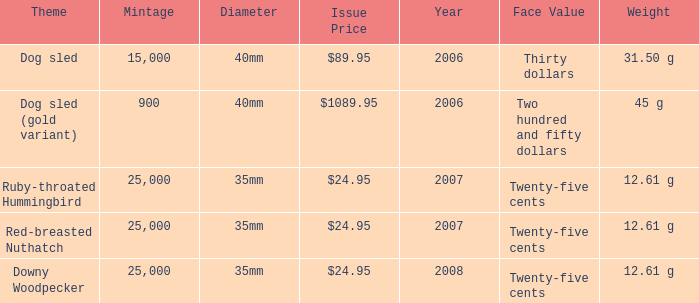What is the Year of the Coin with an Issue Price of $1089.95 and Mintage less than 900? None. 